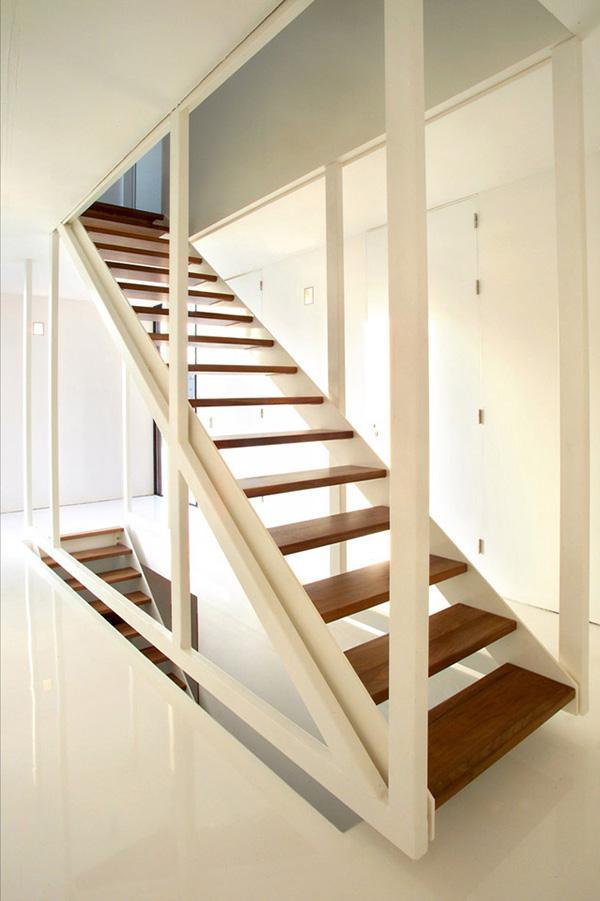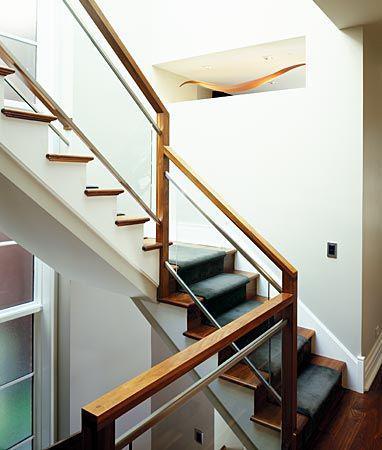The first image is the image on the left, the second image is the image on the right. For the images displayed, is the sentence "The vertical posts on the stairway are all wood." factually correct? Answer yes or no. Yes. The first image is the image on the left, the second image is the image on the right. For the images displayed, is the sentence "One image shows a side view of stairs that ascend to the right and have a handrail with vertical supports spaced apart instead of close together." factually correct? Answer yes or no. No. 